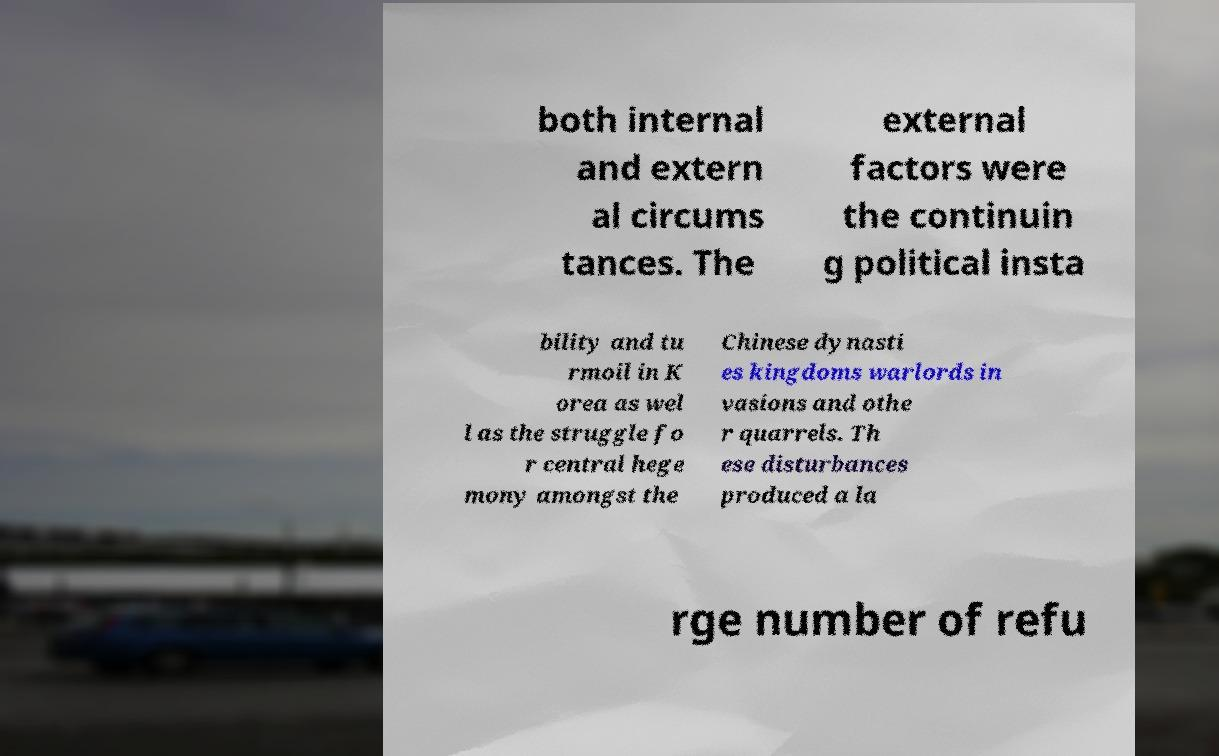Can you accurately transcribe the text from the provided image for me? both internal and extern al circums tances. The external factors were the continuin g political insta bility and tu rmoil in K orea as wel l as the struggle fo r central hege mony amongst the Chinese dynasti es kingdoms warlords in vasions and othe r quarrels. Th ese disturbances produced a la rge number of refu 